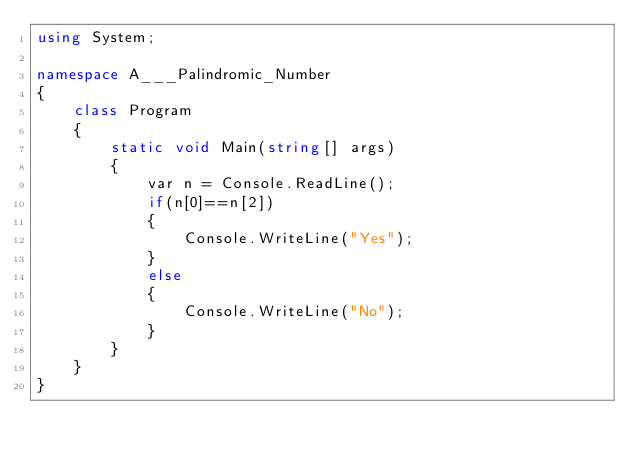<code> <loc_0><loc_0><loc_500><loc_500><_C#_>using System;

namespace A___Palindromic_Number
{
    class Program
    {
        static void Main(string[] args)
        {
            var n = Console.ReadLine();
            if(n[0]==n[2])
            {
                Console.WriteLine("Yes");
            }
            else
            {
                Console.WriteLine("No");
            }
        }
    }
}</code> 